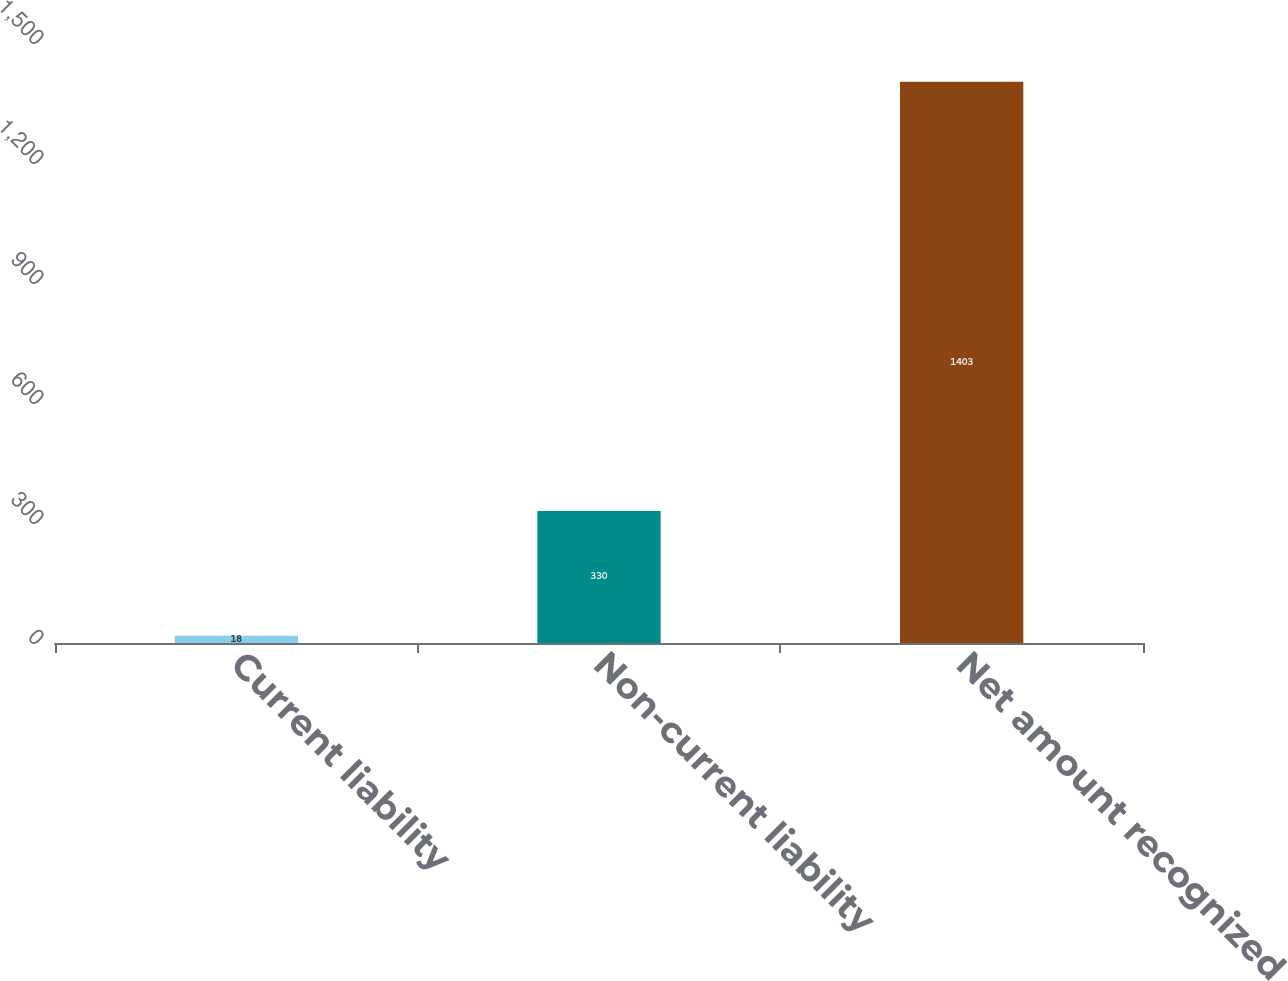<chart> <loc_0><loc_0><loc_500><loc_500><bar_chart><fcel>Current liability<fcel>Non-current liability<fcel>Net amount recognized<nl><fcel>18<fcel>330<fcel>1403<nl></chart> 